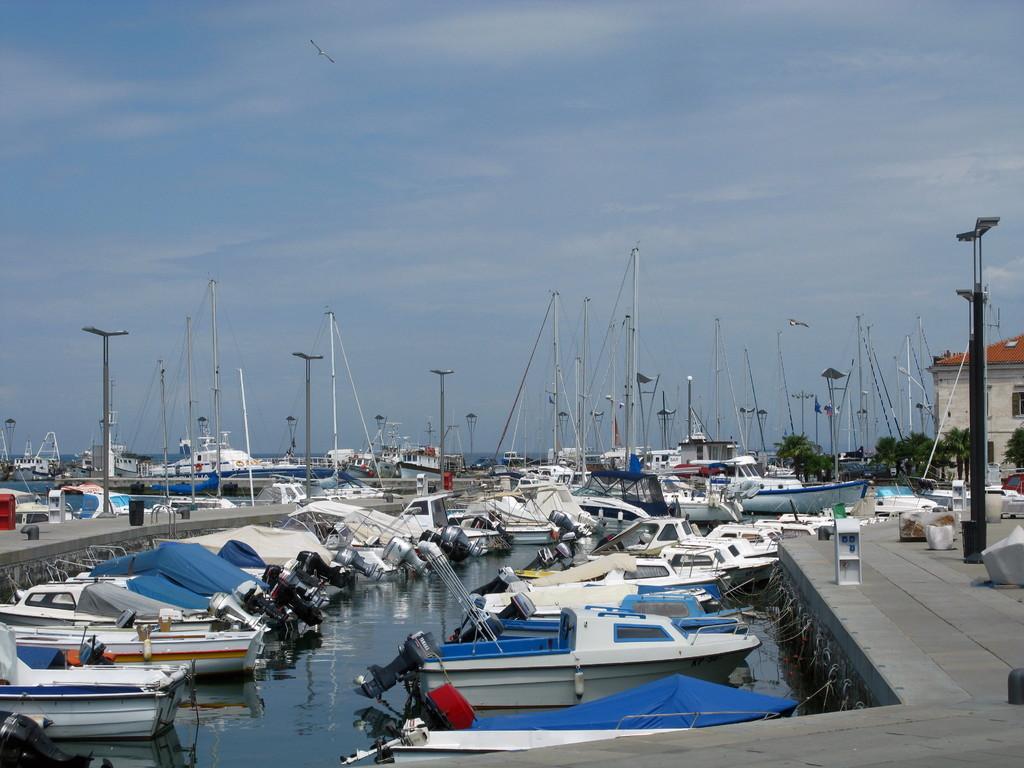Please provide a concise description of this image. In this picture we can see boats on water, platform, poles, trees, house with windows and in the background we can see the sky with clouds. 